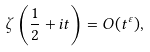<formula> <loc_0><loc_0><loc_500><loc_500>\zeta \left ( { \frac { 1 } { 2 } } + i t \right ) = O ( t ^ { \varepsilon } ) ,</formula> 